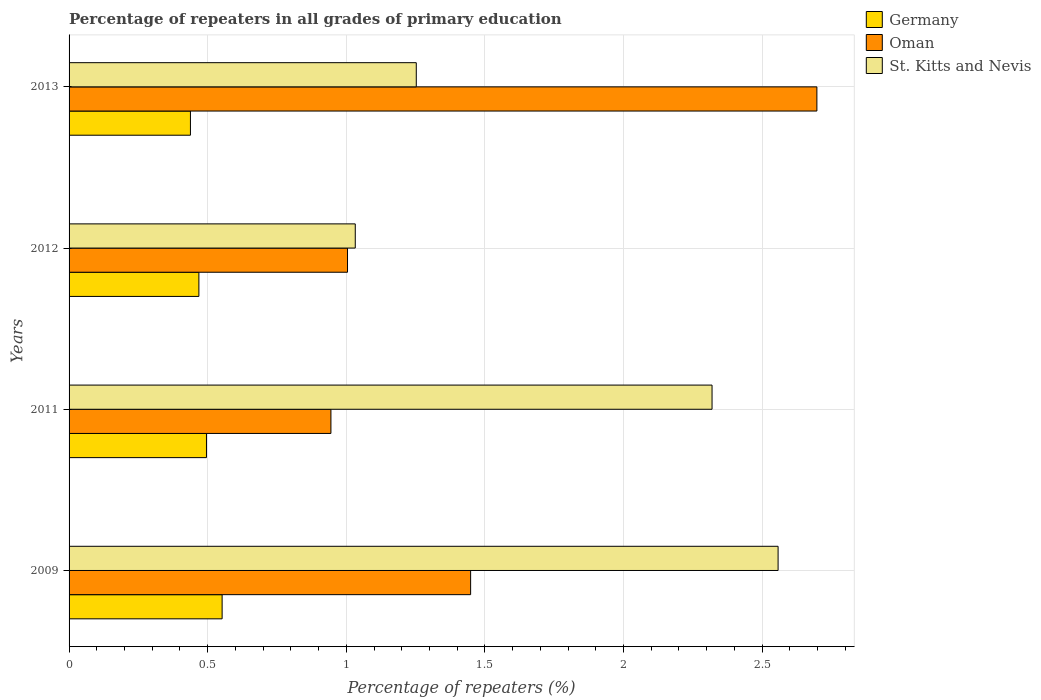How many groups of bars are there?
Provide a succinct answer. 4. How many bars are there on the 2nd tick from the bottom?
Provide a short and direct response. 3. In how many cases, is the number of bars for a given year not equal to the number of legend labels?
Offer a very short reply. 0. What is the percentage of repeaters in Oman in 2013?
Provide a succinct answer. 2.7. Across all years, what is the maximum percentage of repeaters in Germany?
Your answer should be very brief. 0.55. Across all years, what is the minimum percentage of repeaters in Germany?
Provide a short and direct response. 0.44. In which year was the percentage of repeaters in St. Kitts and Nevis minimum?
Ensure brevity in your answer.  2012. What is the total percentage of repeaters in Germany in the graph?
Your answer should be compact. 1.95. What is the difference between the percentage of repeaters in Germany in 2012 and that in 2013?
Ensure brevity in your answer.  0.03. What is the difference between the percentage of repeaters in Germany in 2013 and the percentage of repeaters in Oman in 2012?
Give a very brief answer. -0.57. What is the average percentage of repeaters in Oman per year?
Keep it short and to the point. 1.52. In the year 2011, what is the difference between the percentage of repeaters in Germany and percentage of repeaters in Oman?
Ensure brevity in your answer.  -0.45. In how many years, is the percentage of repeaters in Oman greater than 2.1 %?
Provide a short and direct response. 1. What is the ratio of the percentage of repeaters in Oman in 2011 to that in 2012?
Provide a short and direct response. 0.94. What is the difference between the highest and the second highest percentage of repeaters in Germany?
Offer a terse response. 0.06. What is the difference between the highest and the lowest percentage of repeaters in Oman?
Your response must be concise. 1.75. In how many years, is the percentage of repeaters in St. Kitts and Nevis greater than the average percentage of repeaters in St. Kitts and Nevis taken over all years?
Offer a terse response. 2. What does the 2nd bar from the top in 2009 represents?
Your answer should be very brief. Oman. Is it the case that in every year, the sum of the percentage of repeaters in St. Kitts and Nevis and percentage of repeaters in Germany is greater than the percentage of repeaters in Oman?
Provide a succinct answer. No. What is the difference between two consecutive major ticks on the X-axis?
Your answer should be very brief. 0.5. Are the values on the major ticks of X-axis written in scientific E-notation?
Your answer should be very brief. No. Does the graph contain any zero values?
Provide a succinct answer. No. How many legend labels are there?
Provide a succinct answer. 3. How are the legend labels stacked?
Ensure brevity in your answer.  Vertical. What is the title of the graph?
Your answer should be compact. Percentage of repeaters in all grades of primary education. Does "Sierra Leone" appear as one of the legend labels in the graph?
Give a very brief answer. No. What is the label or title of the X-axis?
Provide a succinct answer. Percentage of repeaters (%). What is the Percentage of repeaters (%) of Germany in 2009?
Your answer should be very brief. 0.55. What is the Percentage of repeaters (%) in Oman in 2009?
Your answer should be very brief. 1.45. What is the Percentage of repeaters (%) in St. Kitts and Nevis in 2009?
Give a very brief answer. 2.56. What is the Percentage of repeaters (%) of Germany in 2011?
Provide a succinct answer. 0.5. What is the Percentage of repeaters (%) of Oman in 2011?
Give a very brief answer. 0.94. What is the Percentage of repeaters (%) in St. Kitts and Nevis in 2011?
Give a very brief answer. 2.32. What is the Percentage of repeaters (%) of Germany in 2012?
Your answer should be very brief. 0.47. What is the Percentage of repeaters (%) in Oman in 2012?
Give a very brief answer. 1. What is the Percentage of repeaters (%) in St. Kitts and Nevis in 2012?
Your response must be concise. 1.03. What is the Percentage of repeaters (%) in Germany in 2013?
Give a very brief answer. 0.44. What is the Percentage of repeaters (%) of Oman in 2013?
Provide a short and direct response. 2.7. What is the Percentage of repeaters (%) of St. Kitts and Nevis in 2013?
Ensure brevity in your answer.  1.25. Across all years, what is the maximum Percentage of repeaters (%) of Germany?
Give a very brief answer. 0.55. Across all years, what is the maximum Percentage of repeaters (%) in Oman?
Provide a short and direct response. 2.7. Across all years, what is the maximum Percentage of repeaters (%) of St. Kitts and Nevis?
Give a very brief answer. 2.56. Across all years, what is the minimum Percentage of repeaters (%) of Germany?
Offer a very short reply. 0.44. Across all years, what is the minimum Percentage of repeaters (%) in Oman?
Make the answer very short. 0.94. Across all years, what is the minimum Percentage of repeaters (%) of St. Kitts and Nevis?
Your answer should be very brief. 1.03. What is the total Percentage of repeaters (%) of Germany in the graph?
Offer a terse response. 1.95. What is the total Percentage of repeaters (%) of Oman in the graph?
Keep it short and to the point. 6.1. What is the total Percentage of repeaters (%) in St. Kitts and Nevis in the graph?
Your response must be concise. 7.16. What is the difference between the Percentage of repeaters (%) of Germany in 2009 and that in 2011?
Your response must be concise. 0.06. What is the difference between the Percentage of repeaters (%) of Oman in 2009 and that in 2011?
Keep it short and to the point. 0.5. What is the difference between the Percentage of repeaters (%) in St. Kitts and Nevis in 2009 and that in 2011?
Ensure brevity in your answer.  0.24. What is the difference between the Percentage of repeaters (%) in Germany in 2009 and that in 2012?
Offer a very short reply. 0.08. What is the difference between the Percentage of repeaters (%) of Oman in 2009 and that in 2012?
Provide a short and direct response. 0.44. What is the difference between the Percentage of repeaters (%) of St. Kitts and Nevis in 2009 and that in 2012?
Your answer should be very brief. 1.53. What is the difference between the Percentage of repeaters (%) of Germany in 2009 and that in 2013?
Ensure brevity in your answer.  0.11. What is the difference between the Percentage of repeaters (%) of Oman in 2009 and that in 2013?
Your answer should be very brief. -1.25. What is the difference between the Percentage of repeaters (%) in St. Kitts and Nevis in 2009 and that in 2013?
Provide a short and direct response. 1.31. What is the difference between the Percentage of repeaters (%) in Germany in 2011 and that in 2012?
Your answer should be compact. 0.03. What is the difference between the Percentage of repeaters (%) of Oman in 2011 and that in 2012?
Your answer should be compact. -0.06. What is the difference between the Percentage of repeaters (%) of St. Kitts and Nevis in 2011 and that in 2012?
Give a very brief answer. 1.29. What is the difference between the Percentage of repeaters (%) of Germany in 2011 and that in 2013?
Make the answer very short. 0.06. What is the difference between the Percentage of repeaters (%) of Oman in 2011 and that in 2013?
Your answer should be compact. -1.75. What is the difference between the Percentage of repeaters (%) of St. Kitts and Nevis in 2011 and that in 2013?
Keep it short and to the point. 1.07. What is the difference between the Percentage of repeaters (%) in Germany in 2012 and that in 2013?
Provide a short and direct response. 0.03. What is the difference between the Percentage of repeaters (%) of Oman in 2012 and that in 2013?
Your answer should be compact. -1.69. What is the difference between the Percentage of repeaters (%) in St. Kitts and Nevis in 2012 and that in 2013?
Ensure brevity in your answer.  -0.22. What is the difference between the Percentage of repeaters (%) in Germany in 2009 and the Percentage of repeaters (%) in Oman in 2011?
Your answer should be very brief. -0.39. What is the difference between the Percentage of repeaters (%) in Germany in 2009 and the Percentage of repeaters (%) in St. Kitts and Nevis in 2011?
Provide a succinct answer. -1.77. What is the difference between the Percentage of repeaters (%) in Oman in 2009 and the Percentage of repeaters (%) in St. Kitts and Nevis in 2011?
Your response must be concise. -0.87. What is the difference between the Percentage of repeaters (%) in Germany in 2009 and the Percentage of repeaters (%) in Oman in 2012?
Ensure brevity in your answer.  -0.45. What is the difference between the Percentage of repeaters (%) in Germany in 2009 and the Percentage of repeaters (%) in St. Kitts and Nevis in 2012?
Keep it short and to the point. -0.48. What is the difference between the Percentage of repeaters (%) in Oman in 2009 and the Percentage of repeaters (%) in St. Kitts and Nevis in 2012?
Provide a short and direct response. 0.42. What is the difference between the Percentage of repeaters (%) of Germany in 2009 and the Percentage of repeaters (%) of Oman in 2013?
Offer a very short reply. -2.15. What is the difference between the Percentage of repeaters (%) in Germany in 2009 and the Percentage of repeaters (%) in St. Kitts and Nevis in 2013?
Your answer should be compact. -0.7. What is the difference between the Percentage of repeaters (%) in Oman in 2009 and the Percentage of repeaters (%) in St. Kitts and Nevis in 2013?
Offer a terse response. 0.2. What is the difference between the Percentage of repeaters (%) of Germany in 2011 and the Percentage of repeaters (%) of Oman in 2012?
Your response must be concise. -0.51. What is the difference between the Percentage of repeaters (%) in Germany in 2011 and the Percentage of repeaters (%) in St. Kitts and Nevis in 2012?
Your answer should be compact. -0.54. What is the difference between the Percentage of repeaters (%) in Oman in 2011 and the Percentage of repeaters (%) in St. Kitts and Nevis in 2012?
Your answer should be compact. -0.09. What is the difference between the Percentage of repeaters (%) of Germany in 2011 and the Percentage of repeaters (%) of Oman in 2013?
Provide a short and direct response. -2.2. What is the difference between the Percentage of repeaters (%) in Germany in 2011 and the Percentage of repeaters (%) in St. Kitts and Nevis in 2013?
Offer a very short reply. -0.76. What is the difference between the Percentage of repeaters (%) in Oman in 2011 and the Percentage of repeaters (%) in St. Kitts and Nevis in 2013?
Your answer should be compact. -0.31. What is the difference between the Percentage of repeaters (%) in Germany in 2012 and the Percentage of repeaters (%) in Oman in 2013?
Offer a terse response. -2.23. What is the difference between the Percentage of repeaters (%) in Germany in 2012 and the Percentage of repeaters (%) in St. Kitts and Nevis in 2013?
Make the answer very short. -0.78. What is the difference between the Percentage of repeaters (%) in Oman in 2012 and the Percentage of repeaters (%) in St. Kitts and Nevis in 2013?
Your answer should be compact. -0.25. What is the average Percentage of repeaters (%) of Germany per year?
Offer a very short reply. 0.49. What is the average Percentage of repeaters (%) of Oman per year?
Your answer should be compact. 1.52. What is the average Percentage of repeaters (%) of St. Kitts and Nevis per year?
Your response must be concise. 1.79. In the year 2009, what is the difference between the Percentage of repeaters (%) in Germany and Percentage of repeaters (%) in Oman?
Keep it short and to the point. -0.9. In the year 2009, what is the difference between the Percentage of repeaters (%) in Germany and Percentage of repeaters (%) in St. Kitts and Nevis?
Offer a very short reply. -2.01. In the year 2009, what is the difference between the Percentage of repeaters (%) of Oman and Percentage of repeaters (%) of St. Kitts and Nevis?
Give a very brief answer. -1.11. In the year 2011, what is the difference between the Percentage of repeaters (%) of Germany and Percentage of repeaters (%) of Oman?
Your answer should be very brief. -0.45. In the year 2011, what is the difference between the Percentage of repeaters (%) of Germany and Percentage of repeaters (%) of St. Kitts and Nevis?
Provide a succinct answer. -1.82. In the year 2011, what is the difference between the Percentage of repeaters (%) of Oman and Percentage of repeaters (%) of St. Kitts and Nevis?
Keep it short and to the point. -1.37. In the year 2012, what is the difference between the Percentage of repeaters (%) in Germany and Percentage of repeaters (%) in Oman?
Provide a short and direct response. -0.54. In the year 2012, what is the difference between the Percentage of repeaters (%) in Germany and Percentage of repeaters (%) in St. Kitts and Nevis?
Give a very brief answer. -0.56. In the year 2012, what is the difference between the Percentage of repeaters (%) in Oman and Percentage of repeaters (%) in St. Kitts and Nevis?
Give a very brief answer. -0.03. In the year 2013, what is the difference between the Percentage of repeaters (%) of Germany and Percentage of repeaters (%) of Oman?
Your answer should be compact. -2.26. In the year 2013, what is the difference between the Percentage of repeaters (%) of Germany and Percentage of repeaters (%) of St. Kitts and Nevis?
Your answer should be compact. -0.81. In the year 2013, what is the difference between the Percentage of repeaters (%) of Oman and Percentage of repeaters (%) of St. Kitts and Nevis?
Give a very brief answer. 1.45. What is the ratio of the Percentage of repeaters (%) in Germany in 2009 to that in 2011?
Your response must be concise. 1.11. What is the ratio of the Percentage of repeaters (%) of Oman in 2009 to that in 2011?
Give a very brief answer. 1.53. What is the ratio of the Percentage of repeaters (%) in St. Kitts and Nevis in 2009 to that in 2011?
Keep it short and to the point. 1.1. What is the ratio of the Percentage of repeaters (%) in Germany in 2009 to that in 2012?
Your response must be concise. 1.18. What is the ratio of the Percentage of repeaters (%) of Oman in 2009 to that in 2012?
Give a very brief answer. 1.44. What is the ratio of the Percentage of repeaters (%) in St. Kitts and Nevis in 2009 to that in 2012?
Your response must be concise. 2.48. What is the ratio of the Percentage of repeaters (%) in Germany in 2009 to that in 2013?
Keep it short and to the point. 1.26. What is the ratio of the Percentage of repeaters (%) of Oman in 2009 to that in 2013?
Your answer should be compact. 0.54. What is the ratio of the Percentage of repeaters (%) in St. Kitts and Nevis in 2009 to that in 2013?
Your answer should be very brief. 2.04. What is the ratio of the Percentage of repeaters (%) in Germany in 2011 to that in 2012?
Your answer should be compact. 1.06. What is the ratio of the Percentage of repeaters (%) in Oman in 2011 to that in 2012?
Make the answer very short. 0.94. What is the ratio of the Percentage of repeaters (%) of St. Kitts and Nevis in 2011 to that in 2012?
Keep it short and to the point. 2.25. What is the ratio of the Percentage of repeaters (%) of Germany in 2011 to that in 2013?
Give a very brief answer. 1.13. What is the ratio of the Percentage of repeaters (%) of Oman in 2011 to that in 2013?
Ensure brevity in your answer.  0.35. What is the ratio of the Percentage of repeaters (%) of St. Kitts and Nevis in 2011 to that in 2013?
Your response must be concise. 1.85. What is the ratio of the Percentage of repeaters (%) of Germany in 2012 to that in 2013?
Your answer should be compact. 1.07. What is the ratio of the Percentage of repeaters (%) in Oman in 2012 to that in 2013?
Give a very brief answer. 0.37. What is the ratio of the Percentage of repeaters (%) in St. Kitts and Nevis in 2012 to that in 2013?
Make the answer very short. 0.82. What is the difference between the highest and the second highest Percentage of repeaters (%) in Germany?
Offer a very short reply. 0.06. What is the difference between the highest and the second highest Percentage of repeaters (%) of Oman?
Your response must be concise. 1.25. What is the difference between the highest and the second highest Percentage of repeaters (%) of St. Kitts and Nevis?
Provide a short and direct response. 0.24. What is the difference between the highest and the lowest Percentage of repeaters (%) in Germany?
Provide a succinct answer. 0.11. What is the difference between the highest and the lowest Percentage of repeaters (%) in Oman?
Keep it short and to the point. 1.75. What is the difference between the highest and the lowest Percentage of repeaters (%) in St. Kitts and Nevis?
Give a very brief answer. 1.53. 